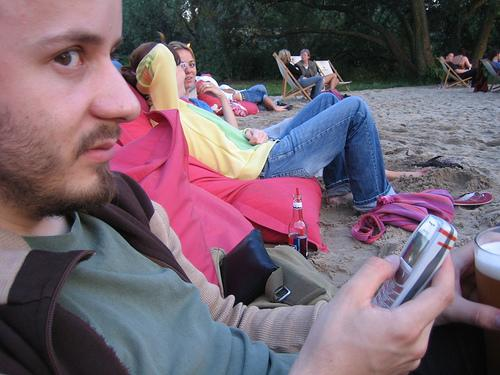What kind of ground are these people sitting on? Please explain your reasoning. sand. The ground is sand. 